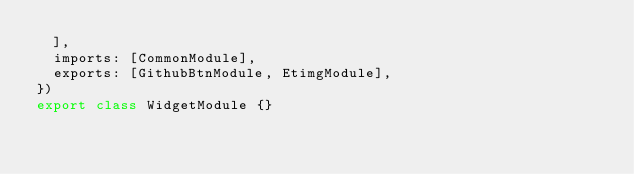Convert code to text. <code><loc_0><loc_0><loc_500><loc_500><_TypeScript_>  ],
  imports: [CommonModule],
  exports: [GithubBtnModule, EtimgModule],
})
export class WidgetModule {}
</code> 